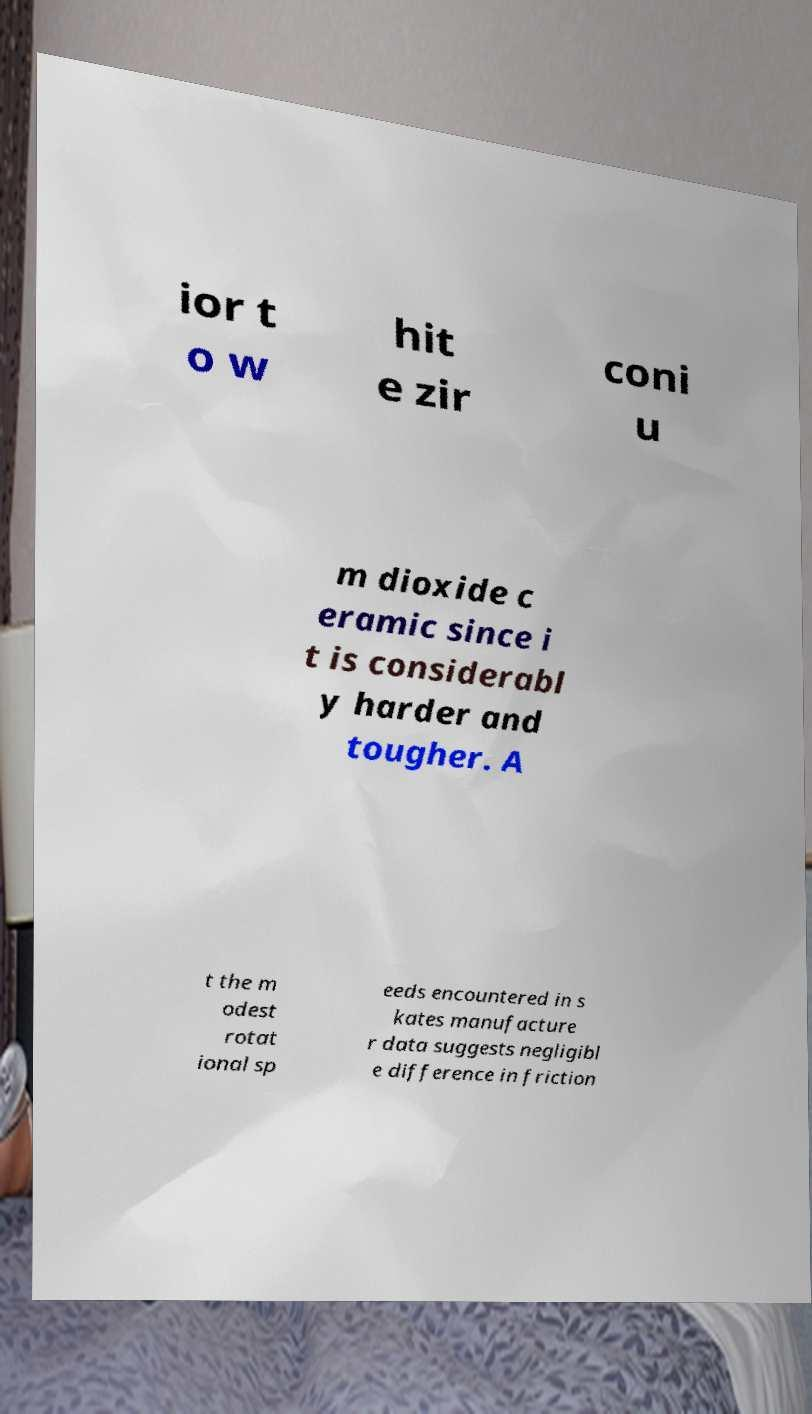There's text embedded in this image that I need extracted. Can you transcribe it verbatim? ior t o w hit e zir coni u m dioxide c eramic since i t is considerabl y harder and tougher. A t the m odest rotat ional sp eeds encountered in s kates manufacture r data suggests negligibl e difference in friction 